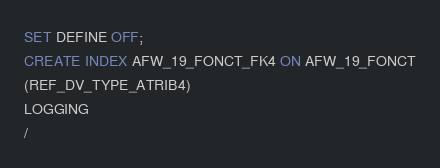Convert code to text. <code><loc_0><loc_0><loc_500><loc_500><_SQL_>SET DEFINE OFF;
CREATE INDEX AFW_19_FONCT_FK4 ON AFW_19_FONCT
(REF_DV_TYPE_ATRIB4)
LOGGING
/
</code> 